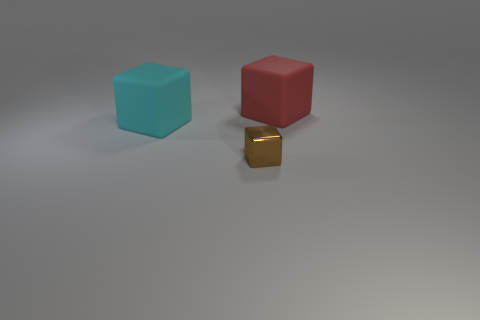Are there any other things that are the same material as the brown object?
Provide a succinct answer. No. Is there anything else that has the same size as the brown shiny cube?
Provide a succinct answer. No. Are there fewer metallic blocks that are on the left side of the brown block than red matte objects?
Make the answer very short. Yes. What is the color of the other matte object that is the same shape as the red thing?
Your response must be concise. Cyan. There is a matte cube that is in front of the red rubber block; is its size the same as the small object?
Keep it short and to the point. No. There is a brown metal block in front of the block right of the brown object; what is its size?
Provide a succinct answer. Small. Is the big cyan object made of the same material as the block that is to the right of the brown thing?
Give a very brief answer. Yes. Is the number of brown cubes that are behind the big red thing less than the number of tiny brown metal cubes in front of the small brown metal block?
Provide a short and direct response. No. What color is the other big thing that is the same material as the large cyan thing?
Ensure brevity in your answer.  Red. Is there a big matte object in front of the big rubber cube to the right of the shiny cube?
Offer a very short reply. Yes. 